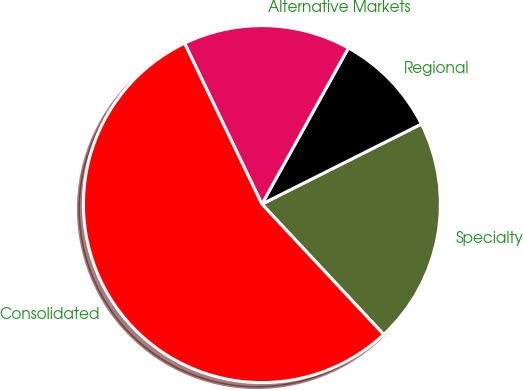<chart> <loc_0><loc_0><loc_500><loc_500><pie_chart><fcel>Specialty<fcel>Regional<fcel>Alternative Markets<fcel>Consolidated<nl><fcel>20.45%<fcel>9.54%<fcel>15.19%<fcel>54.82%<nl></chart> 